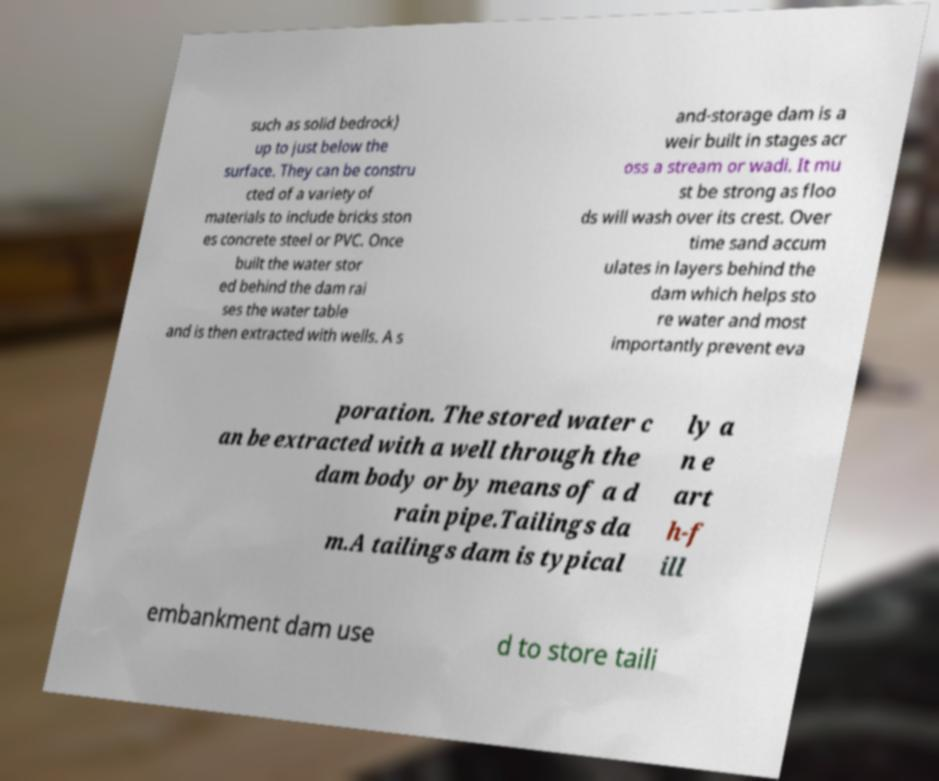I need the written content from this picture converted into text. Can you do that? such as solid bedrock) up to just below the surface. They can be constru cted of a variety of materials to include bricks ston es concrete steel or PVC. Once built the water stor ed behind the dam rai ses the water table and is then extracted with wells. A s and-storage dam is a weir built in stages acr oss a stream or wadi. It mu st be strong as floo ds will wash over its crest. Over time sand accum ulates in layers behind the dam which helps sto re water and most importantly prevent eva poration. The stored water c an be extracted with a well through the dam body or by means of a d rain pipe.Tailings da m.A tailings dam is typical ly a n e art h-f ill embankment dam use d to store taili 